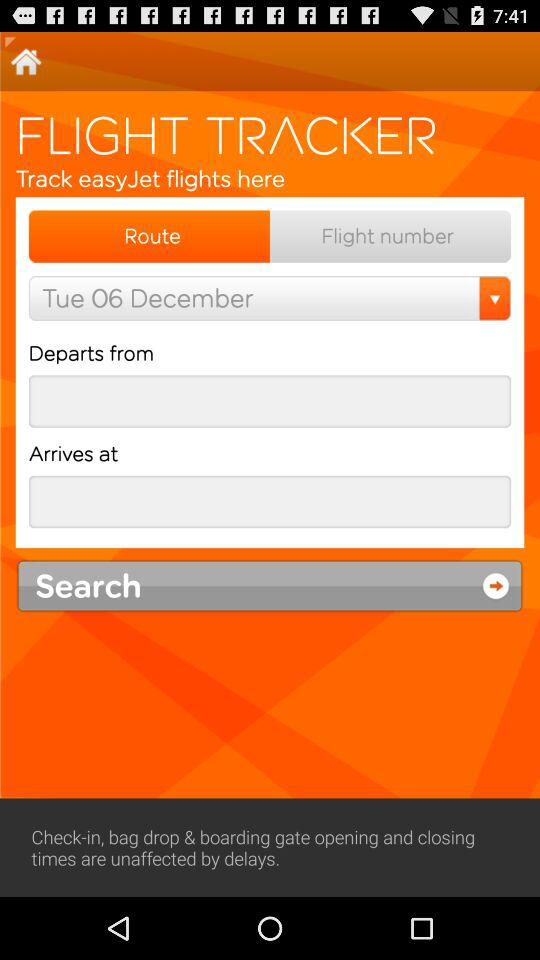Where is the flight departing from?
When the provided information is insufficient, respond with <no answer>. <no answer> 